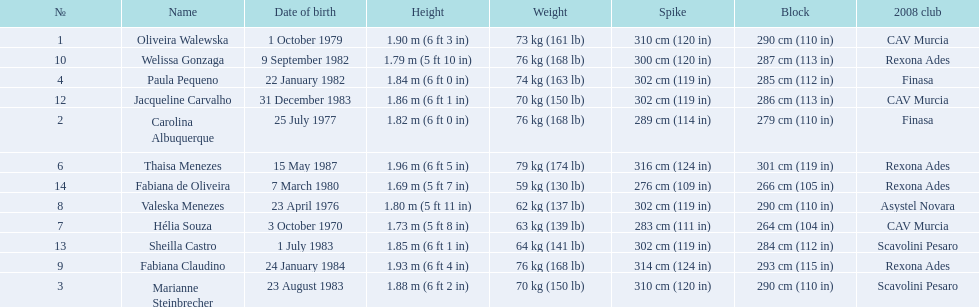How much does fabiana de oliveira weigh? 76 kg (168 lb). How much does helia souza weigh? 63 kg (139 lb). How much does sheilla castro weigh? 64 kg (141 lb). Whose weight did the original question asker incorrectly believe to be the heaviest (they are the second heaviest)? Sheilla Castro. 